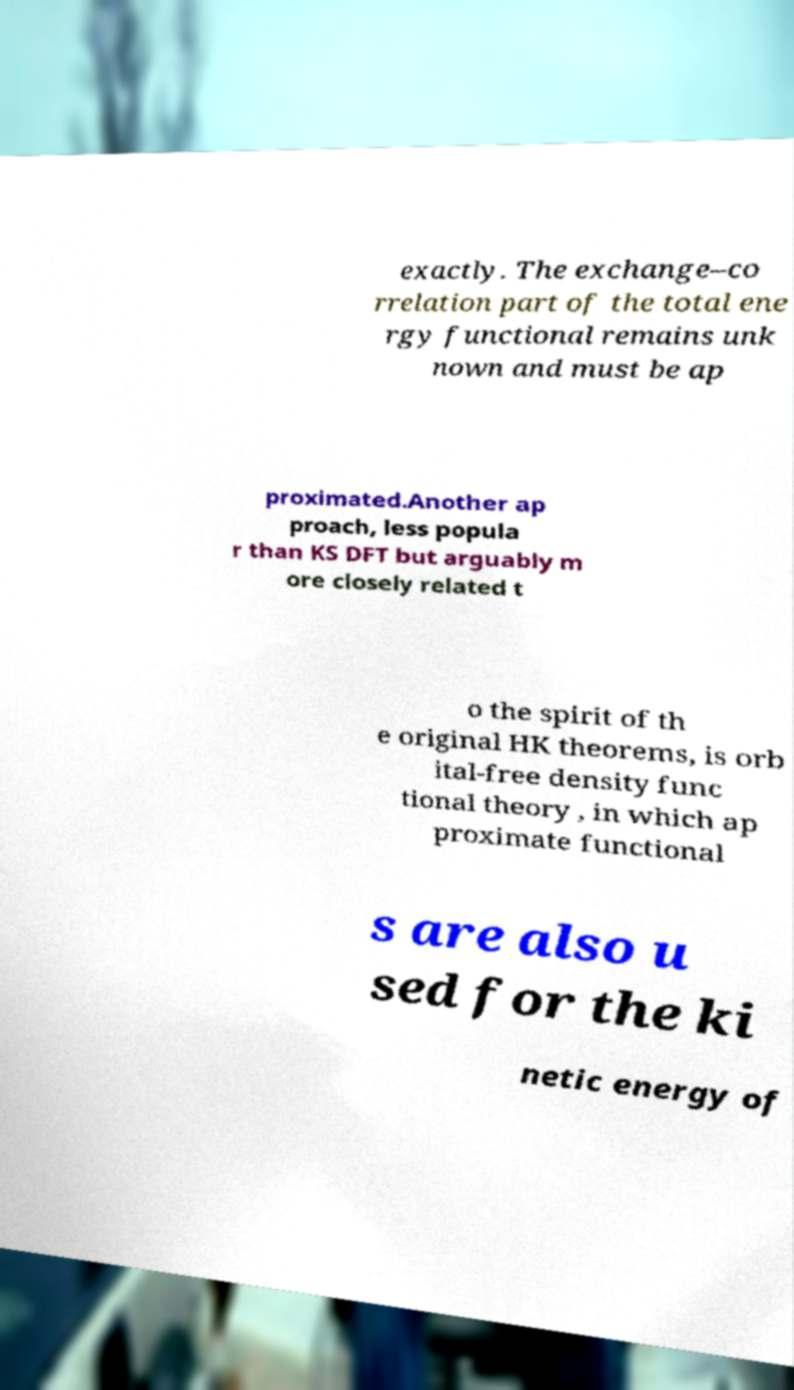Could you assist in decoding the text presented in this image and type it out clearly? exactly. The exchange–co rrelation part of the total ene rgy functional remains unk nown and must be ap proximated.Another ap proach, less popula r than KS DFT but arguably m ore closely related t o the spirit of th e original HK theorems, is orb ital-free density func tional theory , in which ap proximate functional s are also u sed for the ki netic energy of 